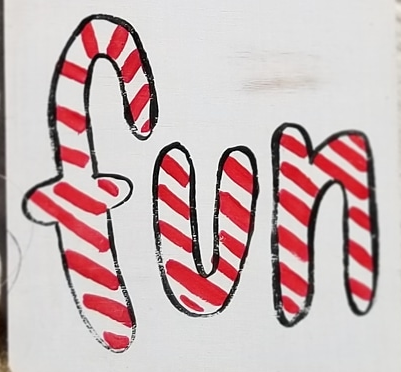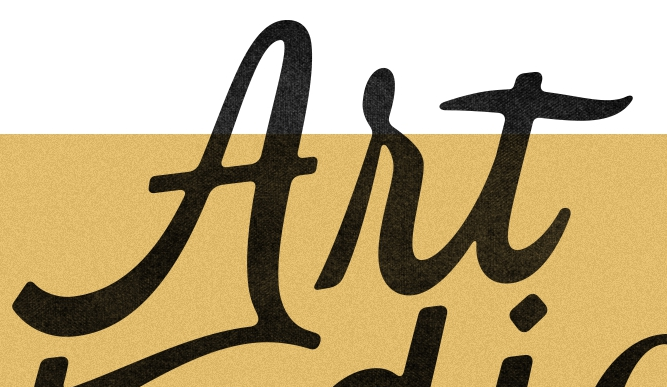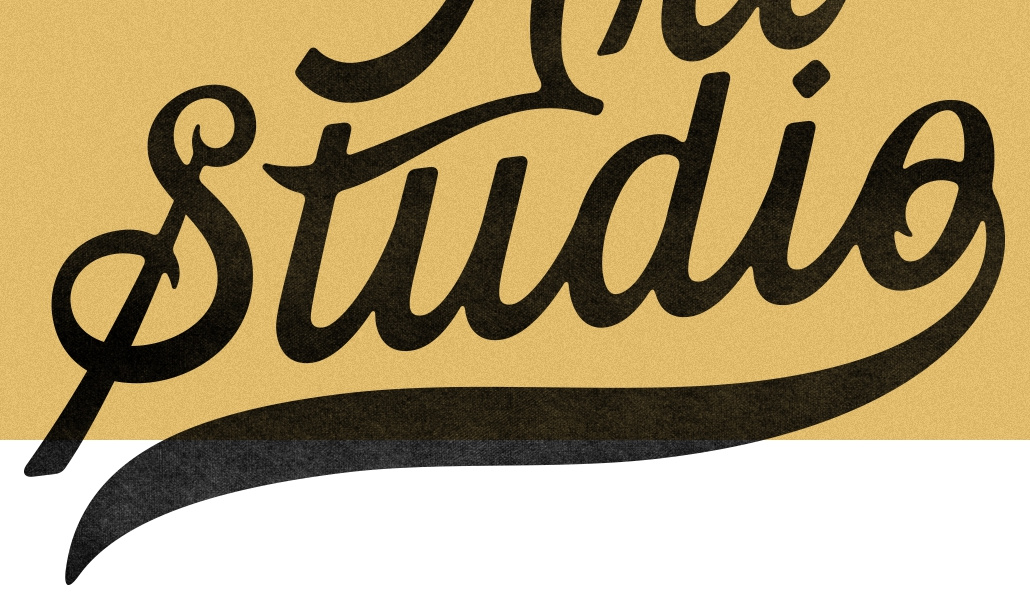What text is displayed in these images sequentially, separated by a semicolon? fun; Art; Studio 